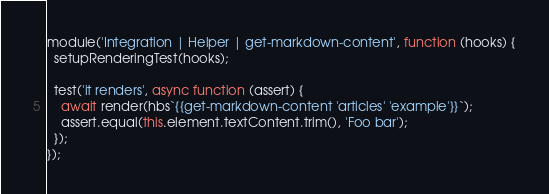<code> <loc_0><loc_0><loc_500><loc_500><_JavaScript_>module('Integration | Helper | get-markdown-content', function (hooks) {
  setupRenderingTest(hooks);

  test('it renders', async function (assert) {
    await render(hbs`{{get-markdown-content 'articles' 'example'}}`);
    assert.equal(this.element.textContent.trim(), 'Foo bar');
  });
});
</code> 